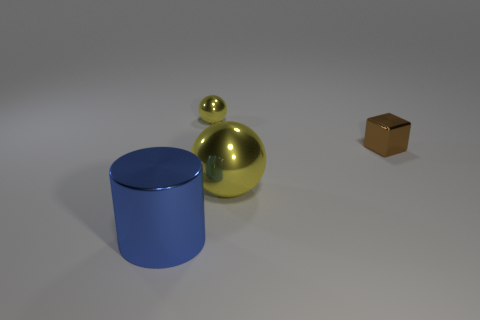What shape is the object that is both on the left side of the brown metallic cube and to the right of the tiny yellow ball?
Your answer should be very brief. Sphere. Are there any large metallic cylinders behind the small brown metal block?
Your answer should be compact. No. Is there anything else that is the same shape as the blue thing?
Your response must be concise. No. Do the small yellow object and the big yellow shiny object have the same shape?
Offer a very short reply. Yes. Are there an equal number of small brown cubes in front of the cylinder and spheres that are behind the brown object?
Your response must be concise. No. What number of large things are cylinders or yellow matte balls?
Your answer should be very brief. 1. Are there an equal number of blue things that are behind the metal block and tiny purple matte things?
Keep it short and to the point. Yes. Are there any metal things behind the big thing that is to the right of the big metallic cylinder?
Keep it short and to the point. Yes. What number of other objects are there of the same color as the big sphere?
Your answer should be very brief. 1. What is the color of the large sphere?
Offer a very short reply. Yellow. 